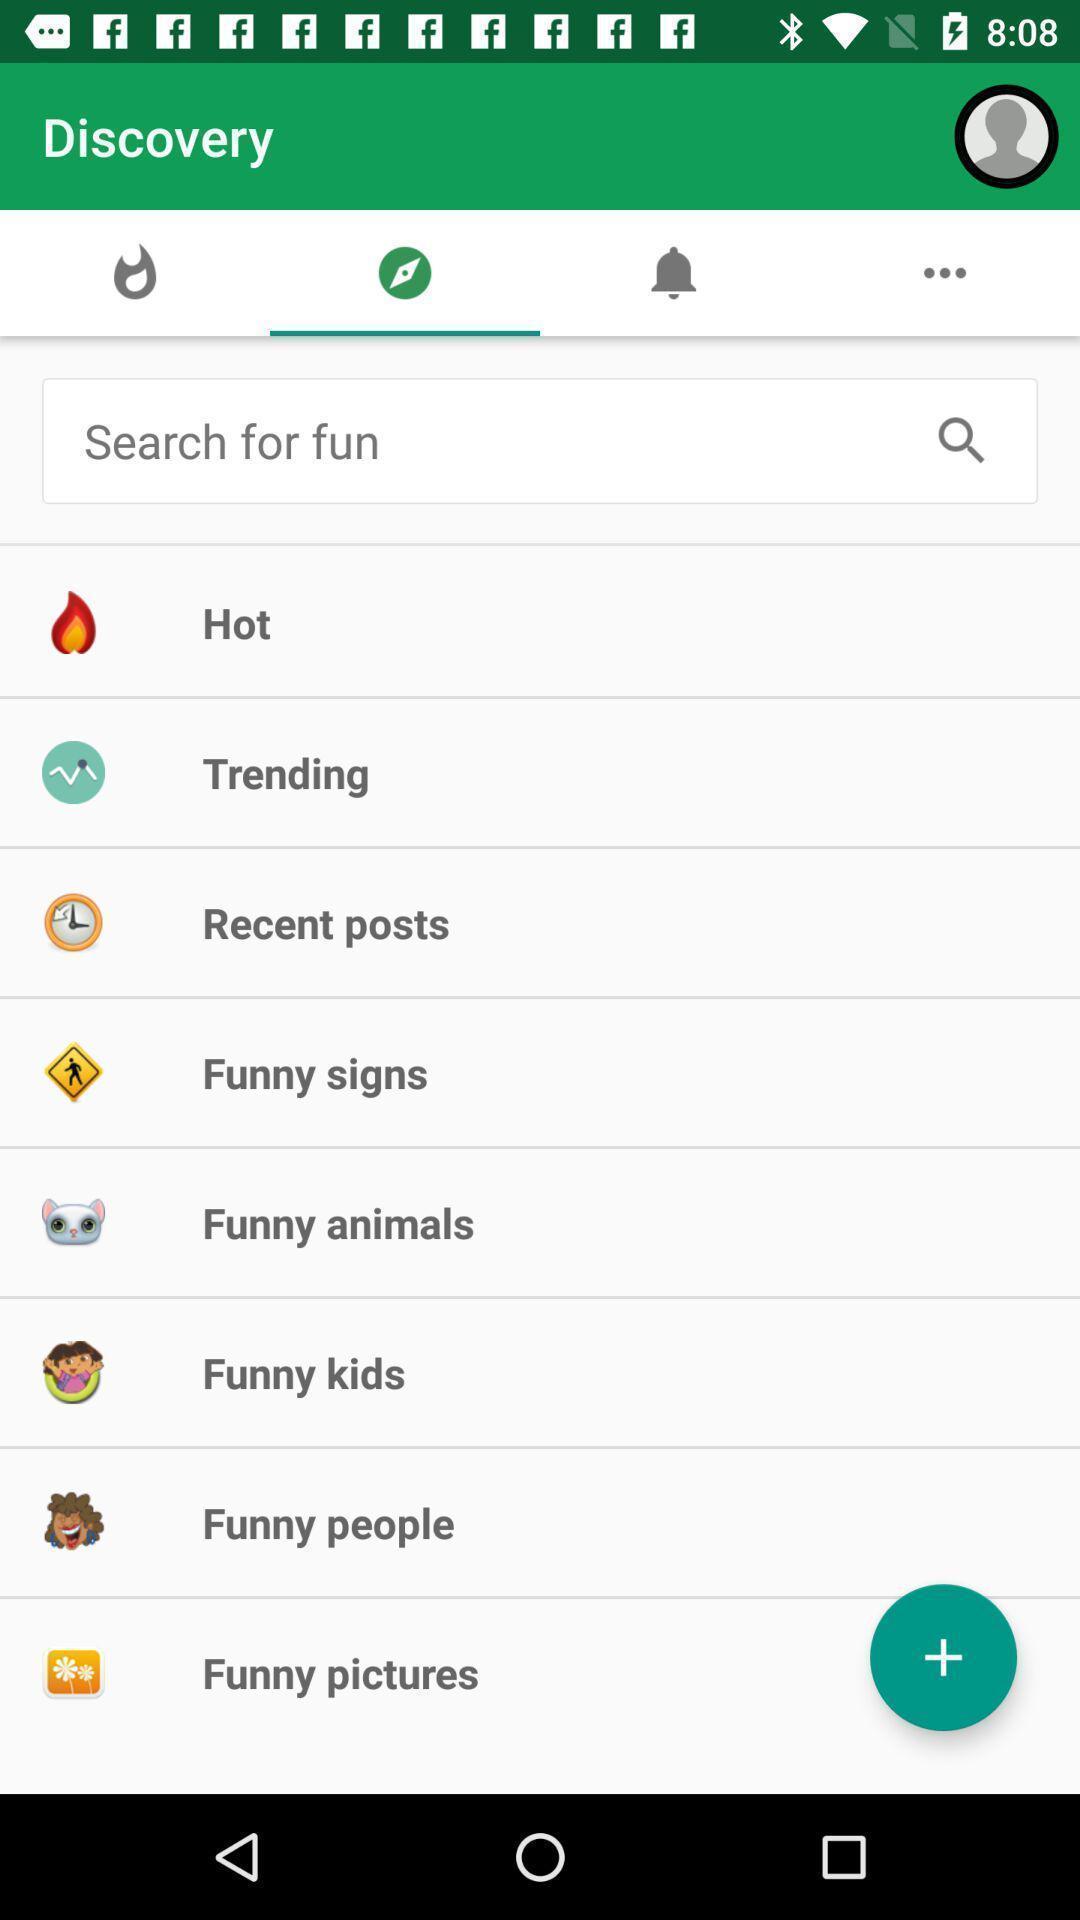Describe the content in this image. Screen displaying search bar in app. 